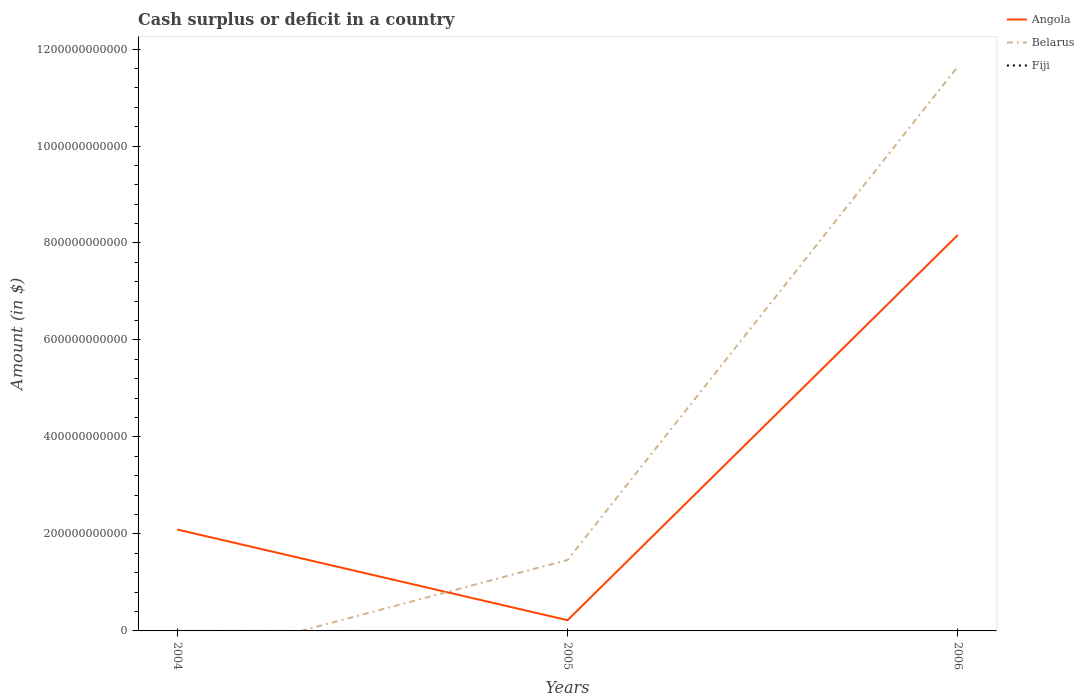Is the number of lines equal to the number of legend labels?
Keep it short and to the point. No. What is the total amount of cash surplus or deficit in Angola in the graph?
Provide a succinct answer. 1.87e+11. What is the difference between the highest and the second highest amount of cash surplus or deficit in Angola?
Your response must be concise. 7.94e+11. Is the amount of cash surplus or deficit in Belarus strictly greater than the amount of cash surplus or deficit in Fiji over the years?
Your answer should be compact. No. How many lines are there?
Keep it short and to the point. 2. How many years are there in the graph?
Provide a succinct answer. 3. What is the difference between two consecutive major ticks on the Y-axis?
Offer a very short reply. 2.00e+11. How are the legend labels stacked?
Give a very brief answer. Vertical. What is the title of the graph?
Ensure brevity in your answer.  Cash surplus or deficit in a country. Does "Aruba" appear as one of the legend labels in the graph?
Your response must be concise. No. What is the label or title of the X-axis?
Your answer should be compact. Years. What is the label or title of the Y-axis?
Make the answer very short. Amount (in $). What is the Amount (in $) of Angola in 2004?
Offer a very short reply. 2.09e+11. What is the Amount (in $) in Angola in 2005?
Your answer should be very brief. 2.21e+1. What is the Amount (in $) of Belarus in 2005?
Provide a succinct answer. 1.46e+11. What is the Amount (in $) of Fiji in 2005?
Provide a succinct answer. 0. What is the Amount (in $) in Angola in 2006?
Your answer should be compact. 8.17e+11. What is the Amount (in $) of Belarus in 2006?
Your answer should be very brief. 1.16e+12. Across all years, what is the maximum Amount (in $) in Angola?
Offer a terse response. 8.17e+11. Across all years, what is the maximum Amount (in $) of Belarus?
Offer a terse response. 1.16e+12. Across all years, what is the minimum Amount (in $) of Angola?
Offer a very short reply. 2.21e+1. Across all years, what is the minimum Amount (in $) of Belarus?
Your answer should be compact. 0. What is the total Amount (in $) in Angola in the graph?
Provide a succinct answer. 1.05e+12. What is the total Amount (in $) of Belarus in the graph?
Keep it short and to the point. 1.31e+12. What is the total Amount (in $) of Fiji in the graph?
Your answer should be very brief. 0. What is the difference between the Amount (in $) of Angola in 2004 and that in 2005?
Provide a succinct answer. 1.87e+11. What is the difference between the Amount (in $) in Angola in 2004 and that in 2006?
Give a very brief answer. -6.07e+11. What is the difference between the Amount (in $) in Angola in 2005 and that in 2006?
Your answer should be very brief. -7.94e+11. What is the difference between the Amount (in $) of Belarus in 2005 and that in 2006?
Keep it short and to the point. -1.02e+12. What is the difference between the Amount (in $) in Angola in 2004 and the Amount (in $) in Belarus in 2005?
Give a very brief answer. 6.28e+1. What is the difference between the Amount (in $) of Angola in 2004 and the Amount (in $) of Belarus in 2006?
Provide a short and direct response. -9.55e+11. What is the difference between the Amount (in $) of Angola in 2005 and the Amount (in $) of Belarus in 2006?
Ensure brevity in your answer.  -1.14e+12. What is the average Amount (in $) in Angola per year?
Your response must be concise. 3.49e+11. What is the average Amount (in $) in Belarus per year?
Offer a very short reply. 4.37e+11. What is the average Amount (in $) in Fiji per year?
Offer a terse response. 0. In the year 2005, what is the difference between the Amount (in $) of Angola and Amount (in $) of Belarus?
Offer a terse response. -1.24e+11. In the year 2006, what is the difference between the Amount (in $) in Angola and Amount (in $) in Belarus?
Provide a succinct answer. -3.48e+11. What is the ratio of the Amount (in $) in Angola in 2004 to that in 2005?
Your answer should be compact. 9.45. What is the ratio of the Amount (in $) of Angola in 2004 to that in 2006?
Keep it short and to the point. 0.26. What is the ratio of the Amount (in $) of Angola in 2005 to that in 2006?
Offer a terse response. 0.03. What is the ratio of the Amount (in $) of Belarus in 2005 to that in 2006?
Your response must be concise. 0.13. What is the difference between the highest and the second highest Amount (in $) of Angola?
Offer a very short reply. 6.07e+11. What is the difference between the highest and the lowest Amount (in $) of Angola?
Your answer should be compact. 7.94e+11. What is the difference between the highest and the lowest Amount (in $) in Belarus?
Offer a terse response. 1.16e+12. 